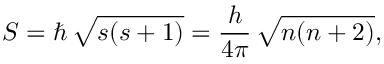Convert formula to latex. <formula><loc_0><loc_0><loc_500><loc_500>S = \hbar { \, } { \sqrt { s ( s + 1 ) } } = { \frac { h } { 4 \pi } } \, { \sqrt { n ( n + 2 ) } } ,</formula> 